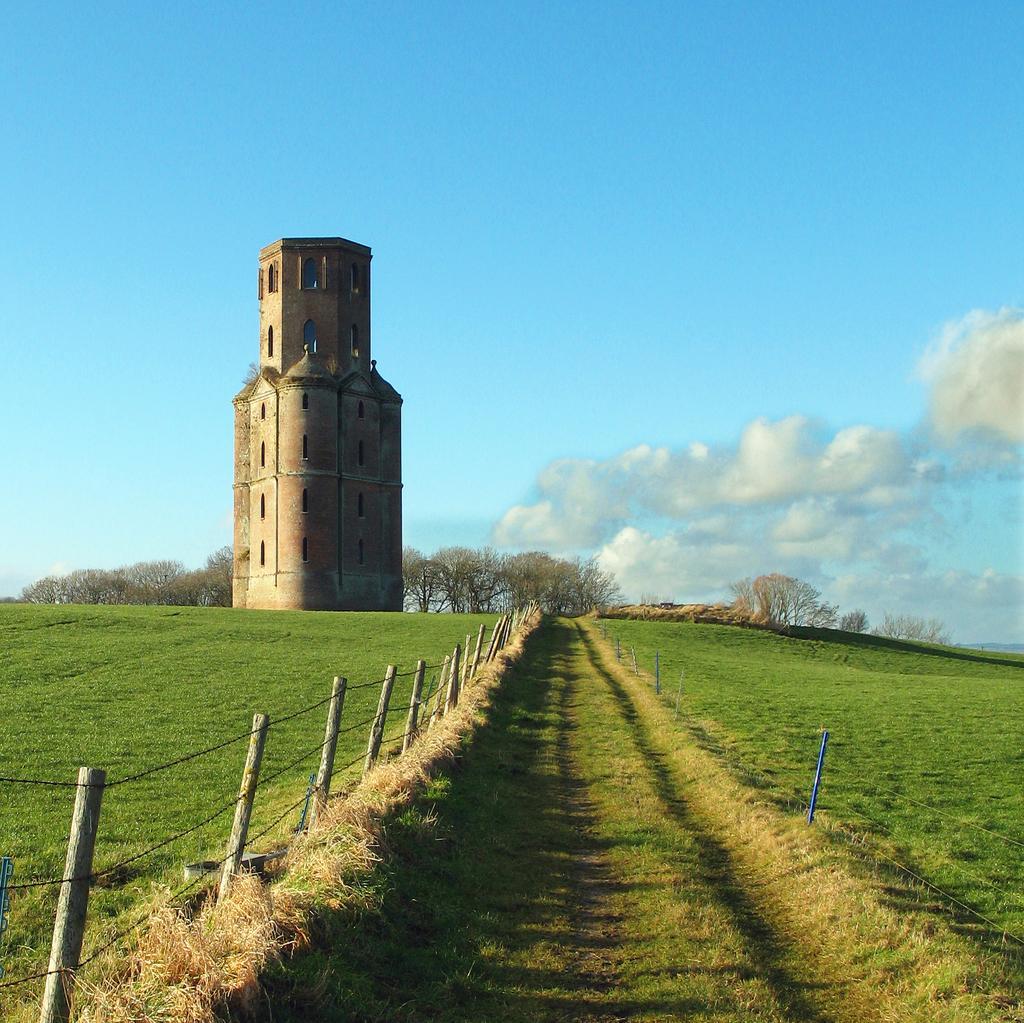Could you give a brief overview of what you see in this image? This picture is clicked outside. In the foreground we can see the green grass and dry grass and we can see the poles and in the background we can see the sky, tower, trees, clouds and some other objects. 